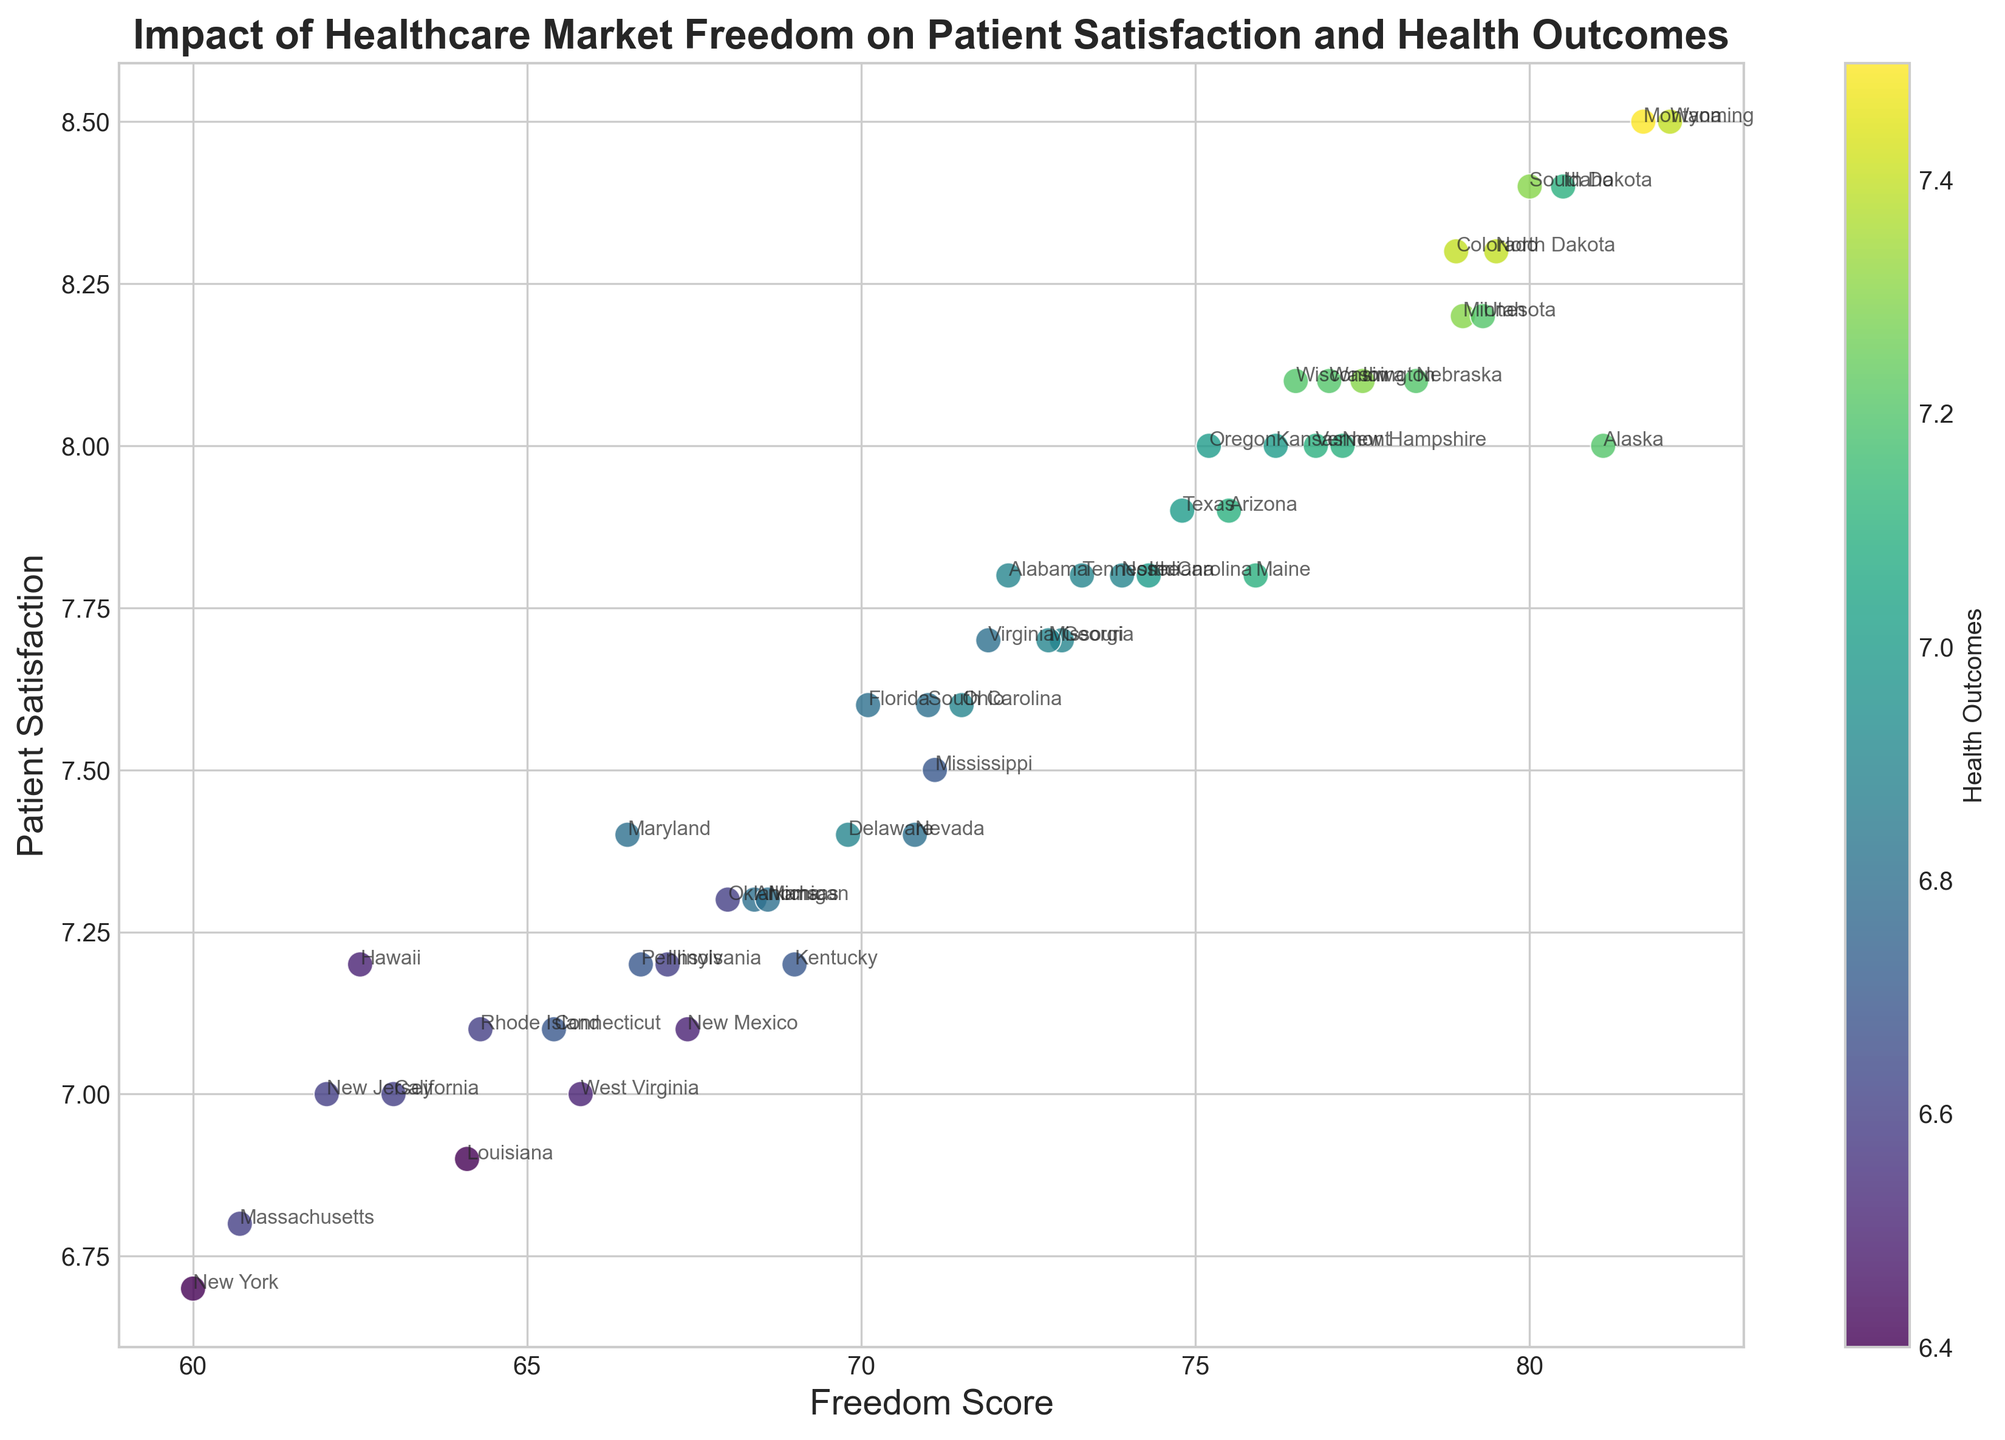Which state has the highest Freedom Score and what are its Patient Satisfaction and Health Outcomes? To find out which state has the highest Freedom Score, locate the point farthest to the right on the x-axis. Wyoming has the highest Freedom Score of 82.1. From the scatter plot, we see that its corresponding points for Patient Satisfaction and Health Outcomes are 8.5 and 7.4, respectively.
Answer: Wyoming, Patient Satisfaction: 8.5, Health Outcomes: 7.4 How does Patient Satisfaction generally correlate with the Freedom Score across states? To understand the correlation, observe the overall trend in the scatter plot. As Freedom Scores increase from left to right, Patient Satisfaction tends to increase as well, suggesting a positive correlation between these two variables.
Answer: Positive correlation Which state has the lowest Health Outcomes, and what are its Freedom Score and Patient Satisfaction values? Find the point with the lowest color value on the color bar (representing Health Outcomes) and locate its corresponding state. Louisiana has the lowest Health Outcomes of 6.4. Its Freedom Score is 64.1, and Patient Satisfaction is 6.9.
Answer: Louisiana, Freedom Score: 64.1, Patient Satisfaction: 6.9 What can you infer about the color distribution in relation to Freedom Scores among states? Observe the spread of colors along the x-axis (Freedom Scores). States with higher Freedom Scores tend to have colors representing higher Health Outcomes, indicating that higher Freedom Scores are generally associated with better Health Outcomes.
Answer: Higher Freedom Scores correlate with better Health Outcomes Which state has the highest Patient Satisfaction and what are its Freedom Score and Health Outcomes? Locate the point farthest upwards on the y-axis, which represents Patient Satisfaction. Montana has the highest Patient Satisfaction of 8.5. Its Freedom Score is 81.7, and Health Outcomes are 7.5.
Answer: Montana, Freedom Score: 81.7, Health Outcomes: 7.5 How many states have both a Freedom Score above 75 and Patient Satisfaction above 8? Identify the scatter points that fall to the right of the vertical line at Freedom Score 75 and above the horizontal line at Patient Satisfaction 8. These states are Colorado, Idaho, Iowa, Nebraska, North Dakota, South Dakota, and Wyoming. There are 7 such states.
Answer: 7 states Compare the Patient Satisfaction levels between states with the lowest and highest Freedom Scores. Identify New York (lowest Freedom Score of 60.0, Patient Satisfaction of 6.7) and Wyoming (highest Freedom Score of 82.1, Patient Satisfaction of 8.5). Compare their Patient Satisfaction: 6.7 vs. 8.5. Wyoming’s Patient Satisfaction is significantly higher.
Answer: New York: 6.7, Wyoming: 8.5 Which state has the closest values for Patient Satisfaction and Health Outcomes, and what are these values? Identify points on the scatter plot where the y-axis (Patient Satisfaction) value is closest to the color bar (Health Outcomes) value. Indiana has Patient Satisfaction of 7.8 and Health Outcomes of 7.0, these values are closest. Check other states to confirm if any is closer.
Answer: Indiana: Patient Satisfaction: 7.8, Health Outcomes: 7.0 Is there a state with a high Freedom Score but relatively low Patient Satisfaction? If so, which state and what are its values? Look for a point towards the right of the x-axis (high Freedom Score) but lower on the y-axis (Patient Satisfaction). Kansas has a high Freedom Score (76.2) but Patient Satisfaction (8.0) can be considered comparatively lower among its peers.
Answer: Kansas: Freedom Score: 76.2, Patient Satisfaction: 8.0 